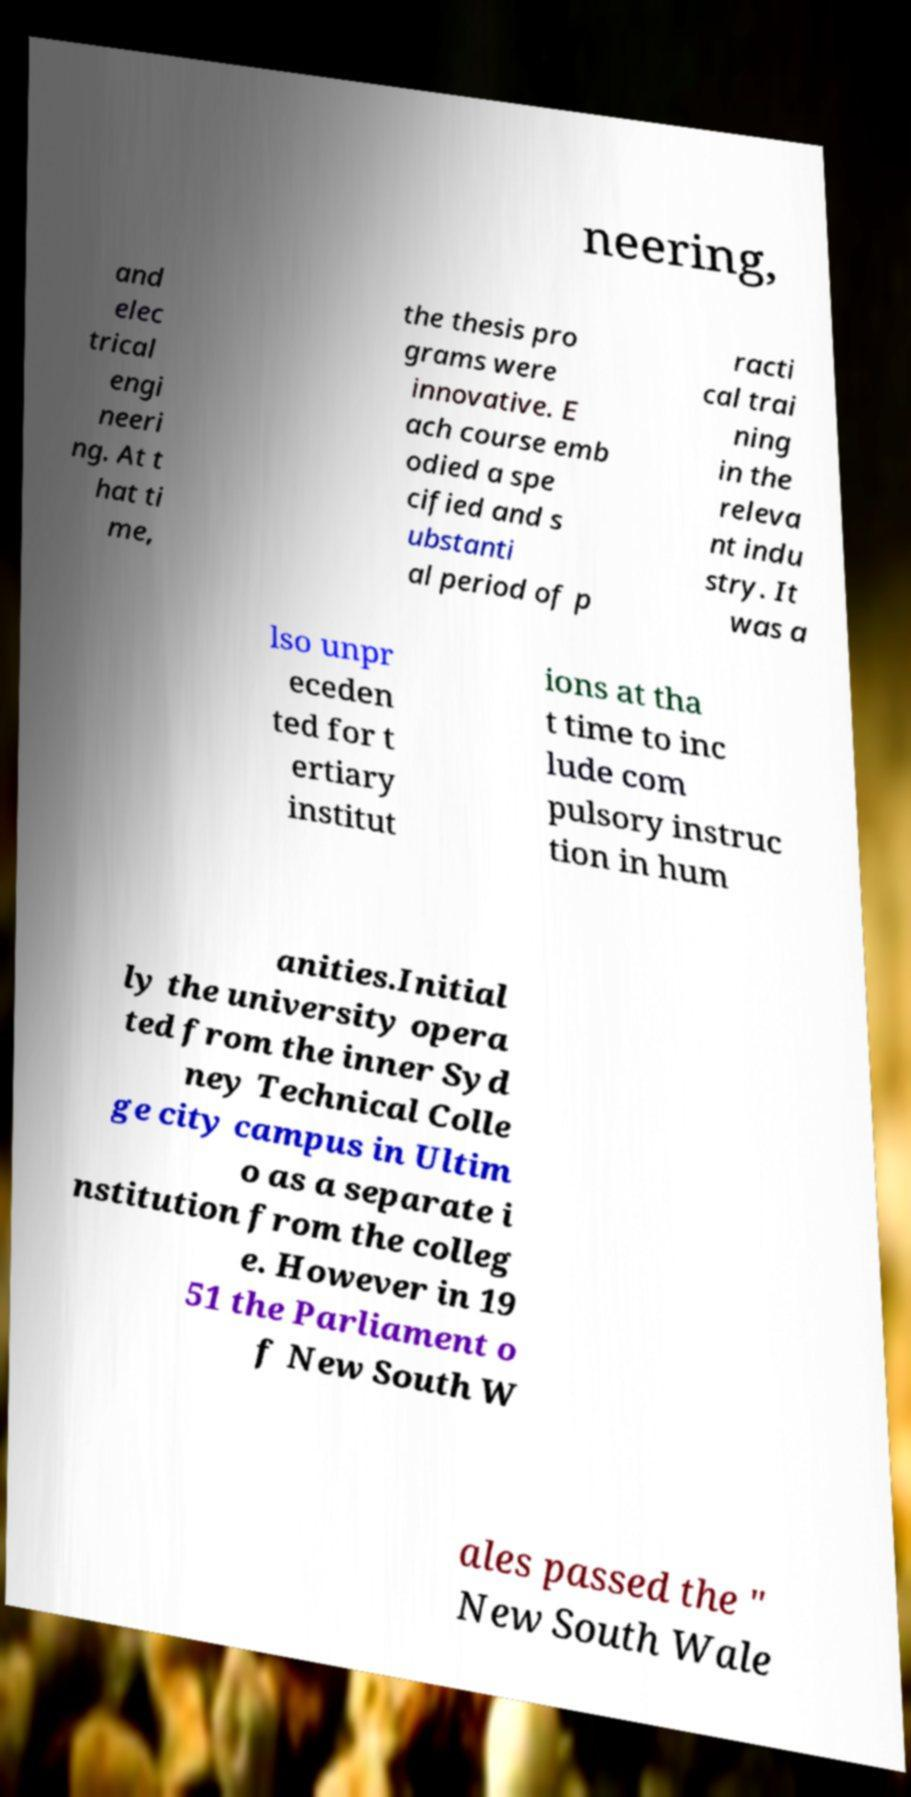There's text embedded in this image that I need extracted. Can you transcribe it verbatim? neering, and elec trical engi neeri ng. At t hat ti me, the thesis pro grams were innovative. E ach course emb odied a spe cified and s ubstanti al period of p racti cal trai ning in the releva nt indu stry. It was a lso unpr eceden ted for t ertiary institut ions at tha t time to inc lude com pulsory instruc tion in hum anities.Initial ly the university opera ted from the inner Syd ney Technical Colle ge city campus in Ultim o as a separate i nstitution from the colleg e. However in 19 51 the Parliament o f New South W ales passed the " New South Wale 